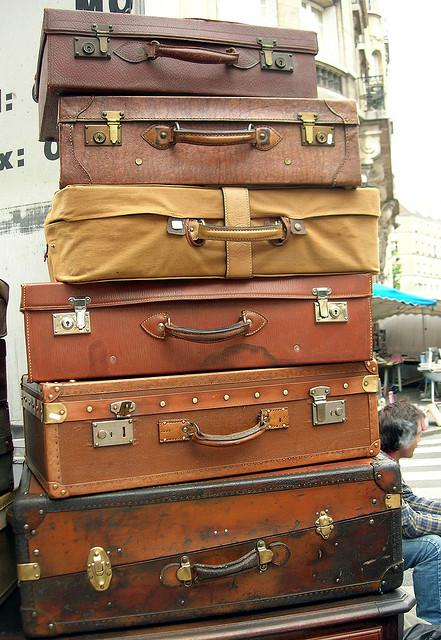What is the building at the back? hotel 